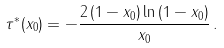Convert formula to latex. <formula><loc_0><loc_0><loc_500><loc_500>\tau ^ { \ast } ( x _ { 0 } ) = - \frac { 2 \left ( 1 - x _ { 0 } \right ) \ln \left ( 1 - x _ { 0 } \right ) } { x _ { 0 } } \, .</formula> 